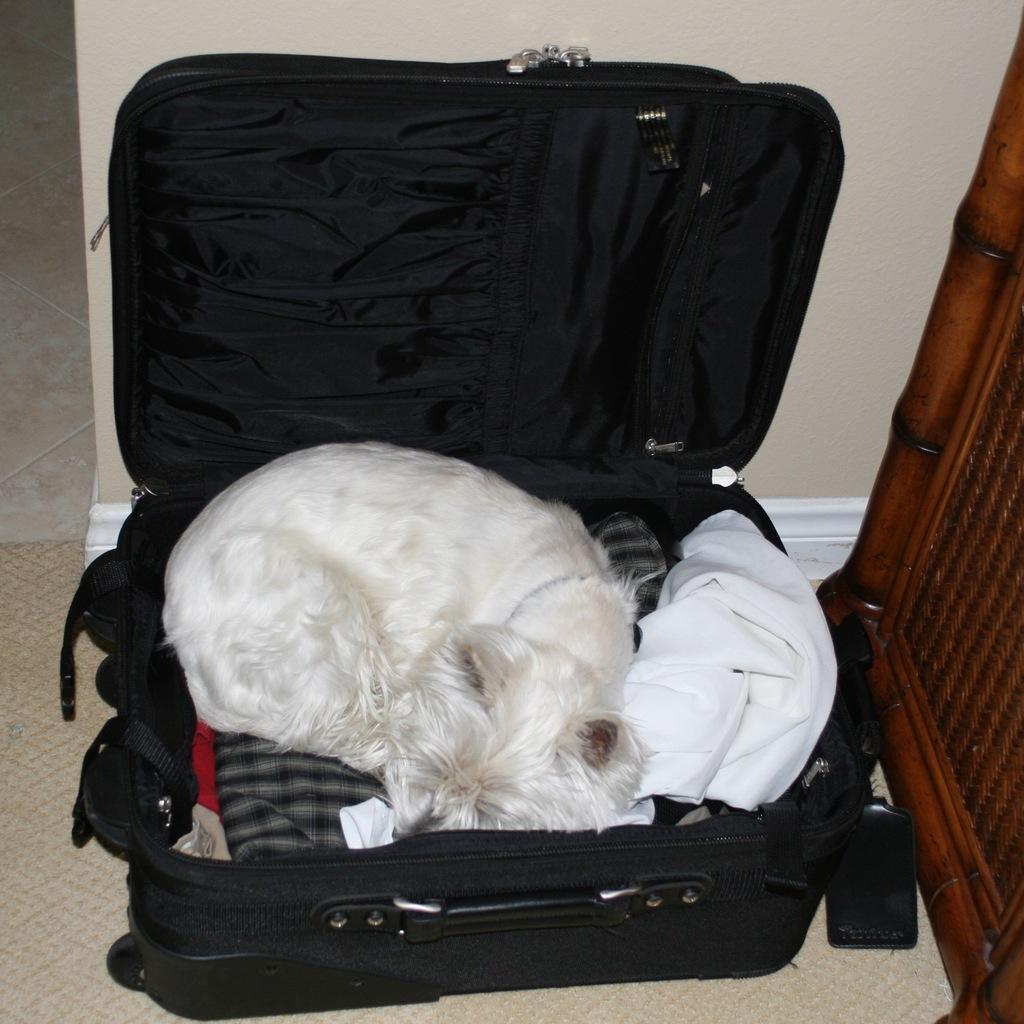Please provide a concise description of this image. In this picture we can see cat sleeping on clothes placed in a suitcase and aside to this we have wooden wall and in background we can see wall. 